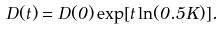<formula> <loc_0><loc_0><loc_500><loc_500>D ( t ) = D ( 0 ) \exp [ t \ln ( 0 . 5 K ) ] .</formula> 